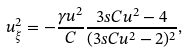<formula> <loc_0><loc_0><loc_500><loc_500>u _ { \xi } ^ { 2 } = - \frac { \gamma u ^ { 2 } } { C } \frac { 3 s C u ^ { 2 } - 4 } { ( 3 s C u ^ { 2 } - 2 ) ^ { 2 } } ,</formula> 